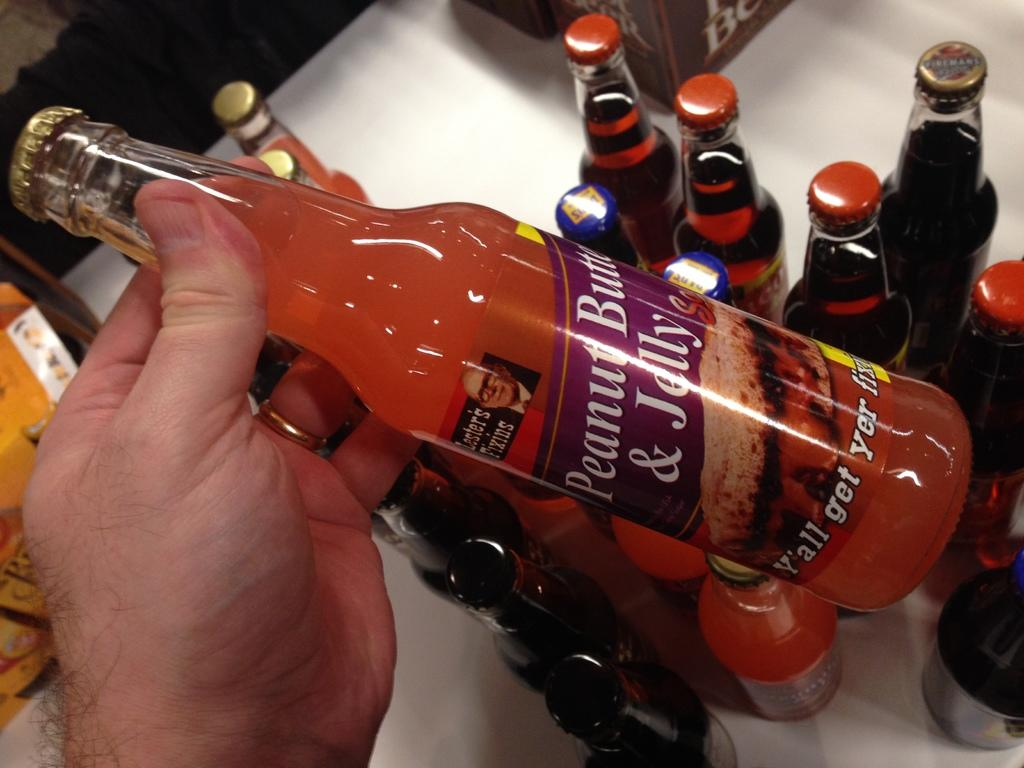Provide a one-sentence caption for the provided image. A person holding a bottle of Lester's Fixins Peanut Butter Jelly above other bottles on a table. 